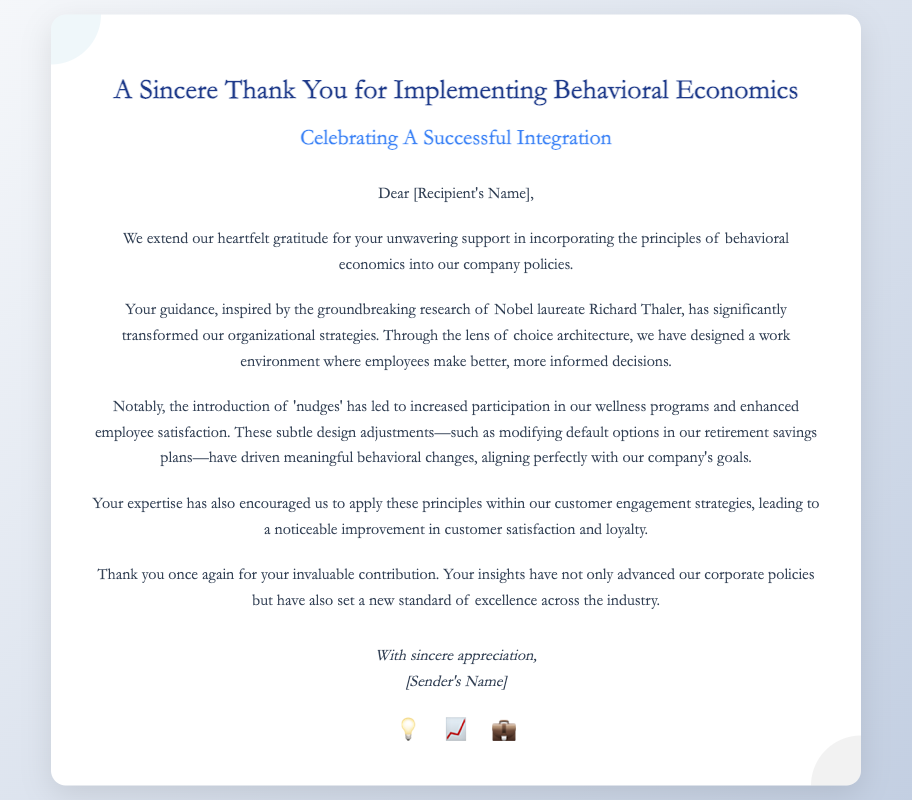What is the title of the card? The title of the card is presented prominently at the top, indicating the purpose of the message.
Answer: A Sincere Thank You for Implementing Behavioral Economics Who is the Nobel laureate mentioned in the card? The card references a notable figure who has contributed to the field of behavioral economics.
Answer: Richard Thaler What type of adjustments does the document refer to as 'nudges'? The document discusses specific strategies or methods applied in the workplace to influence employee behavior positively.
Answer: Subtle design adjustments What is one outcome of applying behavioral economics in the wellness programs? The document notes a specific improvement as a result of the strategies implemented in the company's programs.
Answer: Increased participation What standard has the recipient's insights set? The conclusion of the card reflects on the broader impact of the recipient's contributions to the industry.
Answer: A new standard of excellence 